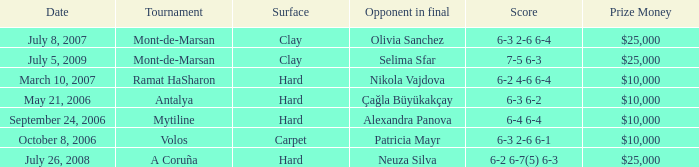What is the score of the match on September 24, 2006? 6-4 6-4. 